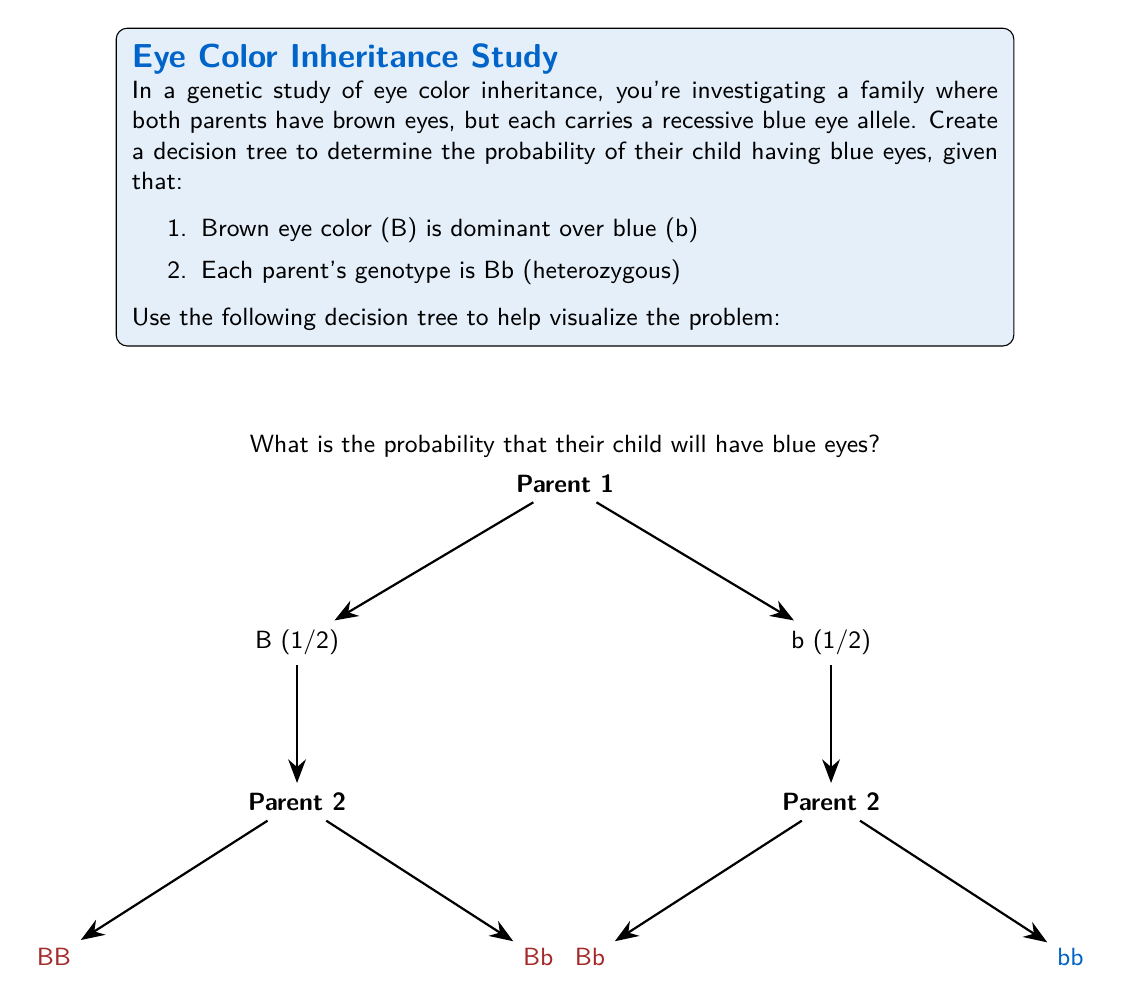What is the answer to this math problem? To solve this problem, we'll follow these steps:

1) First, let's understand the genotypes:
   - B represents the dominant brown eye allele
   - b represents the recessive blue eye allele
   - Both parents are Bb (heterozygous)

2) For a child to have blue eyes, they must inherit the recessive b allele from both parents.

3) The probability of each parent passing on the b allele is 1/2 or 0.5.

4) Using the decision tree, we can see that there are four possible outcomes:
   - BB (Brown eyes)
   - Bb (Brown eyes)
   - Bb (Brown eyes)
   - bb (Blue eyes)

5) The probability of getting bb (blue eyes) is the product of the probabilities along the path leading to bb:

   $$P(\text{blue eyes}) = P(\text{b from Parent 1}) \times P(\text{b from Parent 2})$$
   $$P(\text{blue eyes}) = \frac{1}{2} \times \frac{1}{2} = \frac{1}{4} = 0.25$$

6) Therefore, the probability of their child having blue eyes is 1/4 or 0.25 or 25%.
Answer: $\frac{1}{4}$ or $0.25$ or $25\%$ 